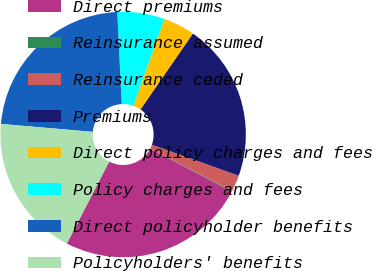<chart> <loc_0><loc_0><loc_500><loc_500><pie_chart><fcel>Direct premiums<fcel>Reinsurance assumed<fcel>Reinsurance ceded<fcel>Premiums<fcel>Direct policy charges and fees<fcel>Policy charges and fees<fcel>Direct policyholder benefits<fcel>Policyholders' benefits<nl><fcel>24.9%<fcel>0.1%<fcel>2.14%<fcel>20.83%<fcel>4.17%<fcel>6.21%<fcel>22.86%<fcel>18.79%<nl></chart> 